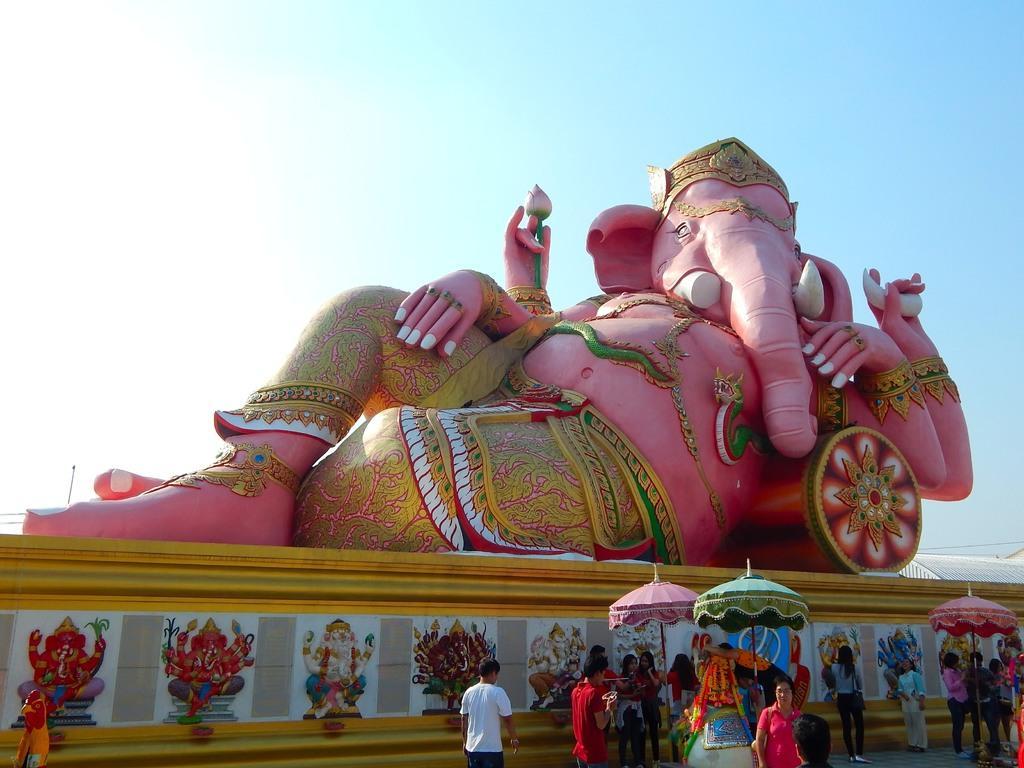Please provide a concise description of this image. This image consists of an idol. At the bottom, there are pictures on the wall. And we can see many people in this image. In the front, there are three umbrellas. At the top, there is sky. 